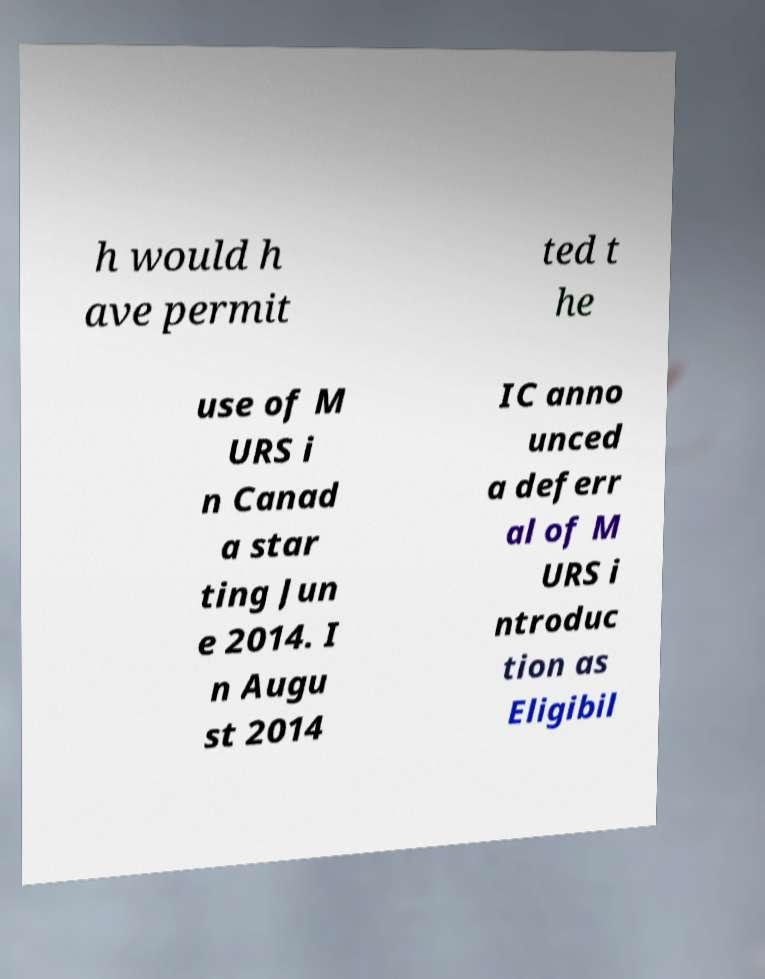There's text embedded in this image that I need extracted. Can you transcribe it verbatim? h would h ave permit ted t he use of M URS i n Canad a star ting Jun e 2014. I n Augu st 2014 IC anno unced a deferr al of M URS i ntroduc tion as Eligibil 